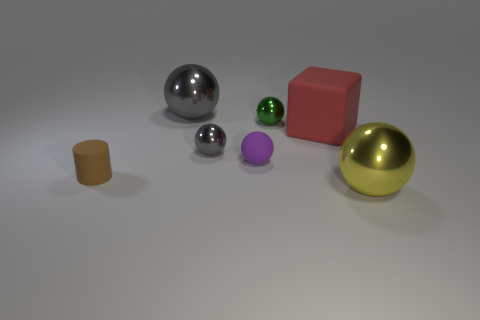What can you infer about the setting based on the objects present? Given the diverse set of objects that vary in shape and material, such as metal spheres, a cube, and a cylinder, it seems this setup is likely a part of a controlled composition, possibly used to demonstrate shading and texture in a 3D modeling software environment or for a light and shadow study in photography. 